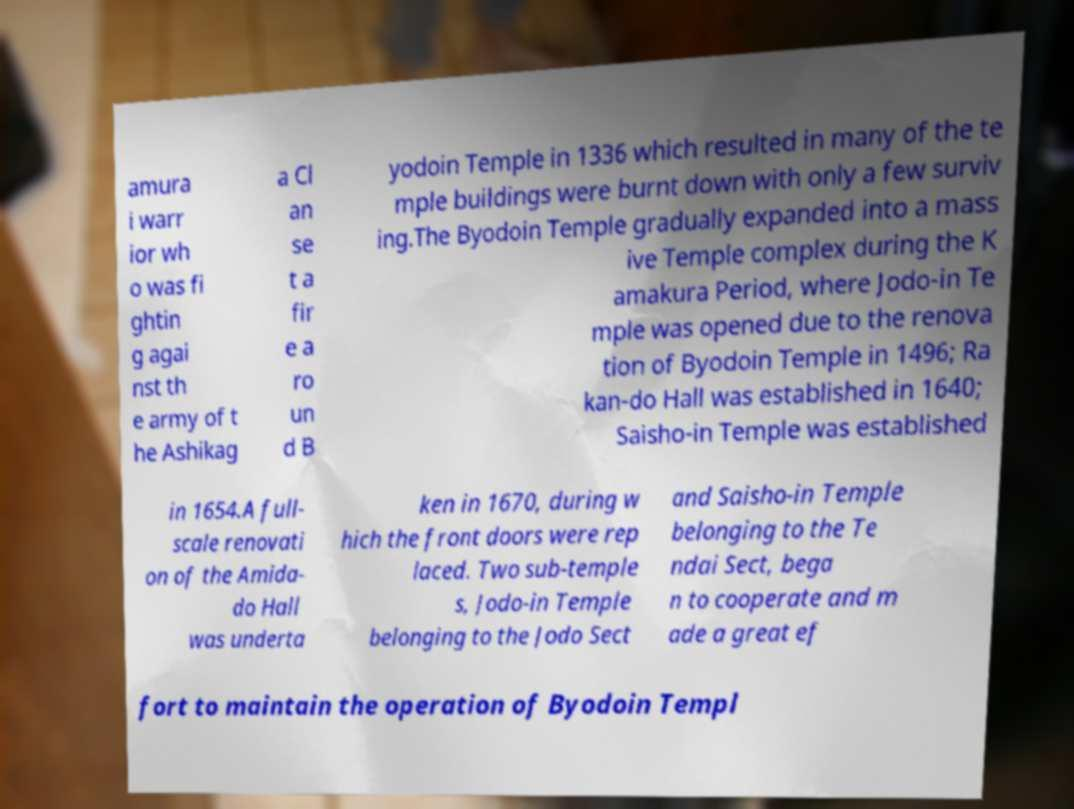Could you assist in decoding the text presented in this image and type it out clearly? amura i warr ior wh o was fi ghtin g agai nst th e army of t he Ashikag a Cl an se t a fir e a ro un d B yodoin Temple in 1336 which resulted in many of the te mple buildings were burnt down with only a few surviv ing.The Byodoin Temple gradually expanded into a mass ive Temple complex during the K amakura Period, where Jodo-in Te mple was opened due to the renova tion of Byodoin Temple in 1496; Ra kan-do Hall was established in 1640; Saisho-in Temple was established in 1654.A full- scale renovati on of the Amida- do Hall was underta ken in 1670, during w hich the front doors were rep laced. Two sub-temple s, Jodo-in Temple belonging to the Jodo Sect and Saisho-in Temple belonging to the Te ndai Sect, bega n to cooperate and m ade a great ef fort to maintain the operation of Byodoin Templ 